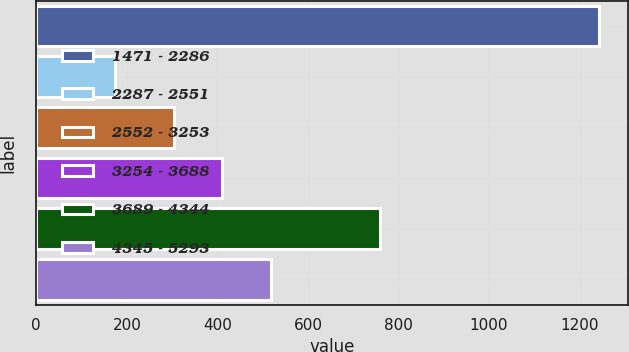<chart> <loc_0><loc_0><loc_500><loc_500><bar_chart><fcel>1471 - 2286<fcel>2287 - 2551<fcel>2552 - 3253<fcel>3254 - 3688<fcel>3689 - 4344<fcel>4345 - 5293<nl><fcel>1244<fcel>174<fcel>304<fcel>411<fcel>760<fcel>518<nl></chart> 